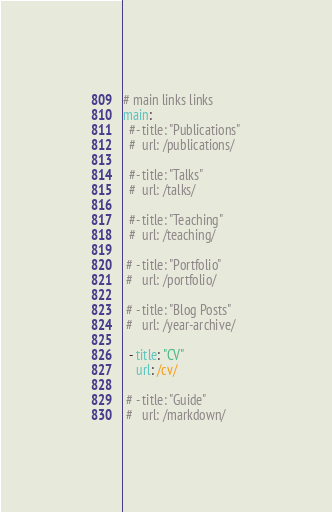<code> <loc_0><loc_0><loc_500><loc_500><_YAML_># main links links
main:
  #- title: "Publications"
  #  url: /publications/

  #- title: "Talks"
  #  url: /talks/    

  #- title: "Teaching"
  #  url: /teaching/    
    
 # - title: "Portfolio"
 #   url: /portfolio/
        
 # - title: "Blog Posts"
 #   url: /year-archive/
    
  - title: "CV"
    url: /cv/
    
 # - title: "Guide"
 #   url: /markdown/
</code> 